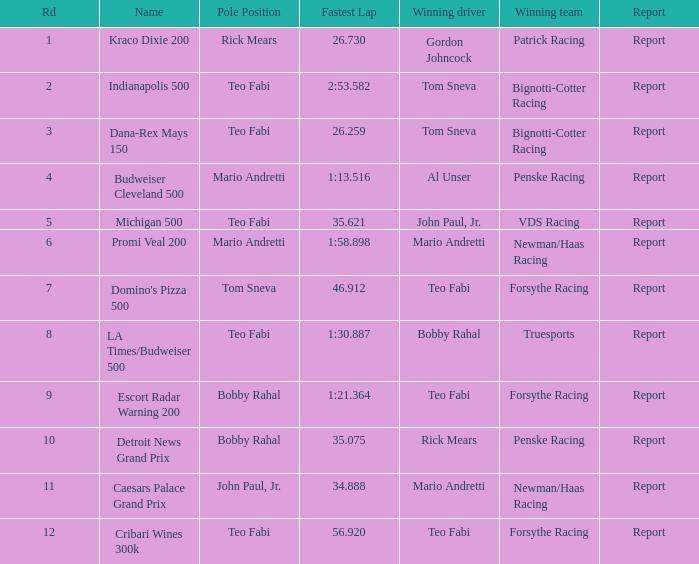At which rd was tom sneva's peak pole position? 7.0. 